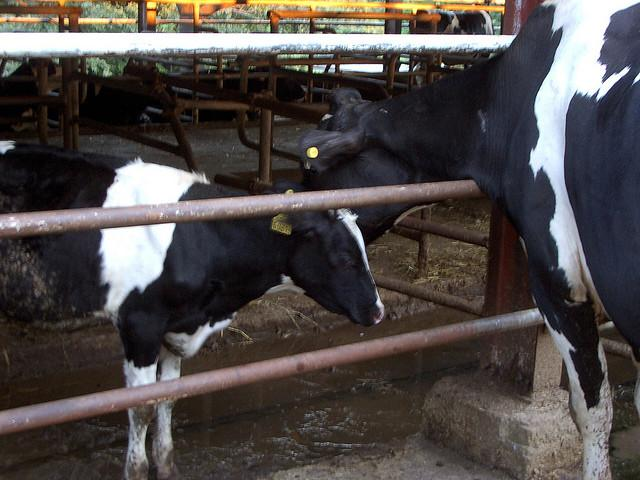Why is the mother cow in a different pen than her calf? milking 